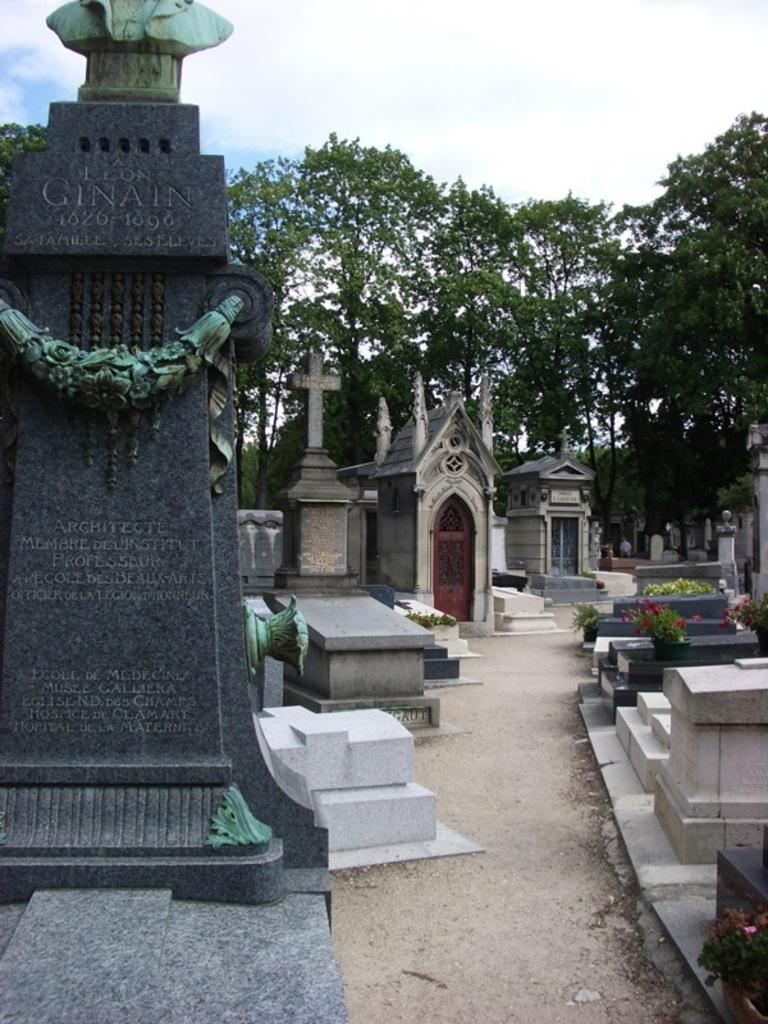What type of location is depicted in the image? The image depicts a graveyard. What can be found in a graveyard? There are headstones and gravestones in the graveyard. What can be seen in the background of the image? There are trees and the sky in the background of the image. How is the sky described in the image? The sky is clear and visible in the background of the image. Where is the kettle located in the image? There is no kettle present in the image. What type of wall can be seen surrounding the graveyard in the image? There is no wall surrounding the graveyard in the image. 